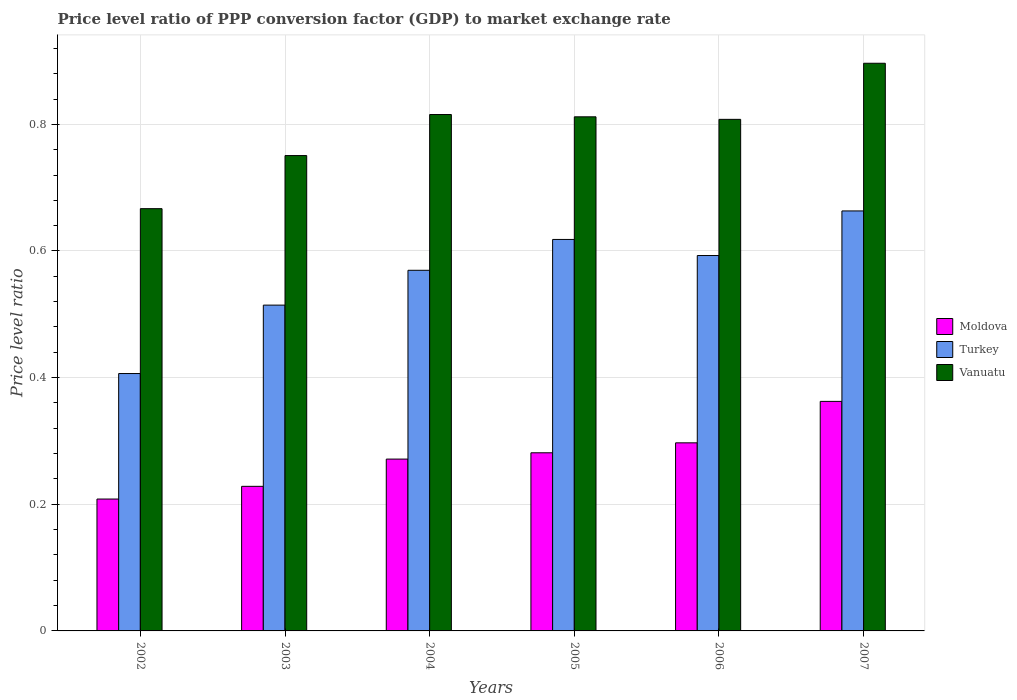Are the number of bars per tick equal to the number of legend labels?
Give a very brief answer. Yes. How many bars are there on the 1st tick from the left?
Give a very brief answer. 3. How many bars are there on the 6th tick from the right?
Give a very brief answer. 3. What is the label of the 2nd group of bars from the left?
Ensure brevity in your answer.  2003. What is the price level ratio in Moldova in 2006?
Ensure brevity in your answer.  0.3. Across all years, what is the maximum price level ratio in Turkey?
Offer a very short reply. 0.66. Across all years, what is the minimum price level ratio in Turkey?
Give a very brief answer. 0.41. In which year was the price level ratio in Turkey maximum?
Offer a very short reply. 2007. What is the total price level ratio in Vanuatu in the graph?
Offer a terse response. 4.75. What is the difference between the price level ratio in Turkey in 2005 and that in 2006?
Give a very brief answer. 0.03. What is the difference between the price level ratio in Vanuatu in 2005 and the price level ratio in Turkey in 2006?
Ensure brevity in your answer.  0.22. What is the average price level ratio in Turkey per year?
Make the answer very short. 0.56. In the year 2006, what is the difference between the price level ratio in Turkey and price level ratio in Moldova?
Your answer should be very brief. 0.3. In how many years, is the price level ratio in Moldova greater than 0.24000000000000002?
Your answer should be very brief. 4. What is the ratio of the price level ratio in Moldova in 2002 to that in 2005?
Your response must be concise. 0.74. Is the price level ratio in Vanuatu in 2004 less than that in 2007?
Offer a very short reply. Yes. Is the difference between the price level ratio in Turkey in 2002 and 2006 greater than the difference between the price level ratio in Moldova in 2002 and 2006?
Provide a short and direct response. No. What is the difference between the highest and the second highest price level ratio in Moldova?
Your answer should be very brief. 0.07. What is the difference between the highest and the lowest price level ratio in Turkey?
Keep it short and to the point. 0.26. In how many years, is the price level ratio in Turkey greater than the average price level ratio in Turkey taken over all years?
Make the answer very short. 4. Is the sum of the price level ratio in Moldova in 2003 and 2005 greater than the maximum price level ratio in Turkey across all years?
Ensure brevity in your answer.  No. What does the 1st bar from the right in 2002 represents?
Ensure brevity in your answer.  Vanuatu. How many bars are there?
Your response must be concise. 18. What is the difference between two consecutive major ticks on the Y-axis?
Make the answer very short. 0.2. Does the graph contain any zero values?
Your answer should be compact. No. Does the graph contain grids?
Your answer should be compact. Yes. Where does the legend appear in the graph?
Ensure brevity in your answer.  Center right. What is the title of the graph?
Provide a succinct answer. Price level ratio of PPP conversion factor (GDP) to market exchange rate. Does "Spain" appear as one of the legend labels in the graph?
Give a very brief answer. No. What is the label or title of the Y-axis?
Your answer should be very brief. Price level ratio. What is the Price level ratio of Moldova in 2002?
Your response must be concise. 0.21. What is the Price level ratio of Turkey in 2002?
Your answer should be compact. 0.41. What is the Price level ratio of Vanuatu in 2002?
Your answer should be compact. 0.67. What is the Price level ratio in Moldova in 2003?
Make the answer very short. 0.23. What is the Price level ratio of Turkey in 2003?
Your response must be concise. 0.51. What is the Price level ratio of Vanuatu in 2003?
Make the answer very short. 0.75. What is the Price level ratio of Moldova in 2004?
Offer a very short reply. 0.27. What is the Price level ratio in Turkey in 2004?
Your answer should be compact. 0.57. What is the Price level ratio in Vanuatu in 2004?
Give a very brief answer. 0.82. What is the Price level ratio of Moldova in 2005?
Ensure brevity in your answer.  0.28. What is the Price level ratio of Turkey in 2005?
Make the answer very short. 0.62. What is the Price level ratio of Vanuatu in 2005?
Provide a succinct answer. 0.81. What is the Price level ratio of Moldova in 2006?
Your response must be concise. 0.3. What is the Price level ratio in Turkey in 2006?
Your answer should be compact. 0.59. What is the Price level ratio of Vanuatu in 2006?
Your answer should be compact. 0.81. What is the Price level ratio of Moldova in 2007?
Provide a short and direct response. 0.36. What is the Price level ratio in Turkey in 2007?
Keep it short and to the point. 0.66. What is the Price level ratio of Vanuatu in 2007?
Give a very brief answer. 0.9. Across all years, what is the maximum Price level ratio in Moldova?
Your answer should be very brief. 0.36. Across all years, what is the maximum Price level ratio in Turkey?
Provide a short and direct response. 0.66. Across all years, what is the maximum Price level ratio of Vanuatu?
Ensure brevity in your answer.  0.9. Across all years, what is the minimum Price level ratio in Moldova?
Provide a short and direct response. 0.21. Across all years, what is the minimum Price level ratio of Turkey?
Your answer should be compact. 0.41. Across all years, what is the minimum Price level ratio of Vanuatu?
Your answer should be very brief. 0.67. What is the total Price level ratio in Moldova in the graph?
Your response must be concise. 1.65. What is the total Price level ratio of Turkey in the graph?
Ensure brevity in your answer.  3.36. What is the total Price level ratio of Vanuatu in the graph?
Your answer should be compact. 4.75. What is the difference between the Price level ratio of Moldova in 2002 and that in 2003?
Your answer should be compact. -0.02. What is the difference between the Price level ratio in Turkey in 2002 and that in 2003?
Your answer should be very brief. -0.11. What is the difference between the Price level ratio in Vanuatu in 2002 and that in 2003?
Ensure brevity in your answer.  -0.08. What is the difference between the Price level ratio in Moldova in 2002 and that in 2004?
Offer a very short reply. -0.06. What is the difference between the Price level ratio in Turkey in 2002 and that in 2004?
Provide a succinct answer. -0.16. What is the difference between the Price level ratio in Vanuatu in 2002 and that in 2004?
Offer a very short reply. -0.15. What is the difference between the Price level ratio in Moldova in 2002 and that in 2005?
Make the answer very short. -0.07. What is the difference between the Price level ratio in Turkey in 2002 and that in 2005?
Give a very brief answer. -0.21. What is the difference between the Price level ratio of Vanuatu in 2002 and that in 2005?
Keep it short and to the point. -0.15. What is the difference between the Price level ratio of Moldova in 2002 and that in 2006?
Make the answer very short. -0.09. What is the difference between the Price level ratio in Turkey in 2002 and that in 2006?
Your answer should be very brief. -0.19. What is the difference between the Price level ratio of Vanuatu in 2002 and that in 2006?
Ensure brevity in your answer.  -0.14. What is the difference between the Price level ratio of Moldova in 2002 and that in 2007?
Provide a succinct answer. -0.15. What is the difference between the Price level ratio of Turkey in 2002 and that in 2007?
Your answer should be compact. -0.26. What is the difference between the Price level ratio in Vanuatu in 2002 and that in 2007?
Offer a terse response. -0.23. What is the difference between the Price level ratio in Moldova in 2003 and that in 2004?
Offer a very short reply. -0.04. What is the difference between the Price level ratio of Turkey in 2003 and that in 2004?
Your answer should be compact. -0.06. What is the difference between the Price level ratio in Vanuatu in 2003 and that in 2004?
Provide a succinct answer. -0.06. What is the difference between the Price level ratio in Moldova in 2003 and that in 2005?
Your response must be concise. -0.05. What is the difference between the Price level ratio of Turkey in 2003 and that in 2005?
Offer a terse response. -0.1. What is the difference between the Price level ratio in Vanuatu in 2003 and that in 2005?
Provide a short and direct response. -0.06. What is the difference between the Price level ratio in Moldova in 2003 and that in 2006?
Ensure brevity in your answer.  -0.07. What is the difference between the Price level ratio in Turkey in 2003 and that in 2006?
Your answer should be very brief. -0.08. What is the difference between the Price level ratio in Vanuatu in 2003 and that in 2006?
Provide a short and direct response. -0.06. What is the difference between the Price level ratio in Moldova in 2003 and that in 2007?
Your response must be concise. -0.13. What is the difference between the Price level ratio in Turkey in 2003 and that in 2007?
Offer a very short reply. -0.15. What is the difference between the Price level ratio in Vanuatu in 2003 and that in 2007?
Your answer should be compact. -0.15. What is the difference between the Price level ratio of Moldova in 2004 and that in 2005?
Offer a terse response. -0.01. What is the difference between the Price level ratio of Turkey in 2004 and that in 2005?
Keep it short and to the point. -0.05. What is the difference between the Price level ratio in Vanuatu in 2004 and that in 2005?
Provide a succinct answer. 0. What is the difference between the Price level ratio in Moldova in 2004 and that in 2006?
Your response must be concise. -0.03. What is the difference between the Price level ratio of Turkey in 2004 and that in 2006?
Give a very brief answer. -0.02. What is the difference between the Price level ratio of Vanuatu in 2004 and that in 2006?
Keep it short and to the point. 0.01. What is the difference between the Price level ratio of Moldova in 2004 and that in 2007?
Your answer should be compact. -0.09. What is the difference between the Price level ratio in Turkey in 2004 and that in 2007?
Provide a succinct answer. -0.09. What is the difference between the Price level ratio of Vanuatu in 2004 and that in 2007?
Your answer should be very brief. -0.08. What is the difference between the Price level ratio of Moldova in 2005 and that in 2006?
Give a very brief answer. -0.02. What is the difference between the Price level ratio of Turkey in 2005 and that in 2006?
Make the answer very short. 0.03. What is the difference between the Price level ratio of Vanuatu in 2005 and that in 2006?
Give a very brief answer. 0. What is the difference between the Price level ratio in Moldova in 2005 and that in 2007?
Provide a succinct answer. -0.08. What is the difference between the Price level ratio in Turkey in 2005 and that in 2007?
Provide a succinct answer. -0.04. What is the difference between the Price level ratio in Vanuatu in 2005 and that in 2007?
Keep it short and to the point. -0.08. What is the difference between the Price level ratio of Moldova in 2006 and that in 2007?
Offer a terse response. -0.07. What is the difference between the Price level ratio in Turkey in 2006 and that in 2007?
Provide a succinct answer. -0.07. What is the difference between the Price level ratio of Vanuatu in 2006 and that in 2007?
Offer a terse response. -0.09. What is the difference between the Price level ratio of Moldova in 2002 and the Price level ratio of Turkey in 2003?
Your response must be concise. -0.31. What is the difference between the Price level ratio in Moldova in 2002 and the Price level ratio in Vanuatu in 2003?
Your answer should be very brief. -0.54. What is the difference between the Price level ratio of Turkey in 2002 and the Price level ratio of Vanuatu in 2003?
Your answer should be very brief. -0.34. What is the difference between the Price level ratio in Moldova in 2002 and the Price level ratio in Turkey in 2004?
Your answer should be compact. -0.36. What is the difference between the Price level ratio in Moldova in 2002 and the Price level ratio in Vanuatu in 2004?
Offer a terse response. -0.61. What is the difference between the Price level ratio of Turkey in 2002 and the Price level ratio of Vanuatu in 2004?
Make the answer very short. -0.41. What is the difference between the Price level ratio in Moldova in 2002 and the Price level ratio in Turkey in 2005?
Your answer should be compact. -0.41. What is the difference between the Price level ratio in Moldova in 2002 and the Price level ratio in Vanuatu in 2005?
Your response must be concise. -0.6. What is the difference between the Price level ratio of Turkey in 2002 and the Price level ratio of Vanuatu in 2005?
Give a very brief answer. -0.41. What is the difference between the Price level ratio of Moldova in 2002 and the Price level ratio of Turkey in 2006?
Offer a terse response. -0.38. What is the difference between the Price level ratio in Moldova in 2002 and the Price level ratio in Vanuatu in 2006?
Offer a very short reply. -0.6. What is the difference between the Price level ratio in Turkey in 2002 and the Price level ratio in Vanuatu in 2006?
Your answer should be very brief. -0.4. What is the difference between the Price level ratio in Moldova in 2002 and the Price level ratio in Turkey in 2007?
Give a very brief answer. -0.46. What is the difference between the Price level ratio in Moldova in 2002 and the Price level ratio in Vanuatu in 2007?
Your answer should be very brief. -0.69. What is the difference between the Price level ratio in Turkey in 2002 and the Price level ratio in Vanuatu in 2007?
Keep it short and to the point. -0.49. What is the difference between the Price level ratio of Moldova in 2003 and the Price level ratio of Turkey in 2004?
Your response must be concise. -0.34. What is the difference between the Price level ratio in Moldova in 2003 and the Price level ratio in Vanuatu in 2004?
Offer a terse response. -0.59. What is the difference between the Price level ratio of Turkey in 2003 and the Price level ratio of Vanuatu in 2004?
Your answer should be compact. -0.3. What is the difference between the Price level ratio in Moldova in 2003 and the Price level ratio in Turkey in 2005?
Your answer should be very brief. -0.39. What is the difference between the Price level ratio of Moldova in 2003 and the Price level ratio of Vanuatu in 2005?
Ensure brevity in your answer.  -0.58. What is the difference between the Price level ratio in Turkey in 2003 and the Price level ratio in Vanuatu in 2005?
Keep it short and to the point. -0.3. What is the difference between the Price level ratio in Moldova in 2003 and the Price level ratio in Turkey in 2006?
Your answer should be compact. -0.36. What is the difference between the Price level ratio of Moldova in 2003 and the Price level ratio of Vanuatu in 2006?
Provide a succinct answer. -0.58. What is the difference between the Price level ratio of Turkey in 2003 and the Price level ratio of Vanuatu in 2006?
Ensure brevity in your answer.  -0.29. What is the difference between the Price level ratio in Moldova in 2003 and the Price level ratio in Turkey in 2007?
Your response must be concise. -0.43. What is the difference between the Price level ratio of Moldova in 2003 and the Price level ratio of Vanuatu in 2007?
Offer a very short reply. -0.67. What is the difference between the Price level ratio of Turkey in 2003 and the Price level ratio of Vanuatu in 2007?
Provide a short and direct response. -0.38. What is the difference between the Price level ratio of Moldova in 2004 and the Price level ratio of Turkey in 2005?
Your answer should be compact. -0.35. What is the difference between the Price level ratio of Moldova in 2004 and the Price level ratio of Vanuatu in 2005?
Make the answer very short. -0.54. What is the difference between the Price level ratio in Turkey in 2004 and the Price level ratio in Vanuatu in 2005?
Give a very brief answer. -0.24. What is the difference between the Price level ratio of Moldova in 2004 and the Price level ratio of Turkey in 2006?
Offer a very short reply. -0.32. What is the difference between the Price level ratio of Moldova in 2004 and the Price level ratio of Vanuatu in 2006?
Give a very brief answer. -0.54. What is the difference between the Price level ratio in Turkey in 2004 and the Price level ratio in Vanuatu in 2006?
Keep it short and to the point. -0.24. What is the difference between the Price level ratio of Moldova in 2004 and the Price level ratio of Turkey in 2007?
Keep it short and to the point. -0.39. What is the difference between the Price level ratio in Moldova in 2004 and the Price level ratio in Vanuatu in 2007?
Keep it short and to the point. -0.63. What is the difference between the Price level ratio in Turkey in 2004 and the Price level ratio in Vanuatu in 2007?
Make the answer very short. -0.33. What is the difference between the Price level ratio of Moldova in 2005 and the Price level ratio of Turkey in 2006?
Your answer should be very brief. -0.31. What is the difference between the Price level ratio in Moldova in 2005 and the Price level ratio in Vanuatu in 2006?
Give a very brief answer. -0.53. What is the difference between the Price level ratio in Turkey in 2005 and the Price level ratio in Vanuatu in 2006?
Provide a short and direct response. -0.19. What is the difference between the Price level ratio in Moldova in 2005 and the Price level ratio in Turkey in 2007?
Offer a very short reply. -0.38. What is the difference between the Price level ratio in Moldova in 2005 and the Price level ratio in Vanuatu in 2007?
Your response must be concise. -0.62. What is the difference between the Price level ratio of Turkey in 2005 and the Price level ratio of Vanuatu in 2007?
Your answer should be very brief. -0.28. What is the difference between the Price level ratio of Moldova in 2006 and the Price level ratio of Turkey in 2007?
Ensure brevity in your answer.  -0.37. What is the difference between the Price level ratio of Moldova in 2006 and the Price level ratio of Vanuatu in 2007?
Ensure brevity in your answer.  -0.6. What is the difference between the Price level ratio of Turkey in 2006 and the Price level ratio of Vanuatu in 2007?
Your response must be concise. -0.3. What is the average Price level ratio of Moldova per year?
Your answer should be compact. 0.27. What is the average Price level ratio of Turkey per year?
Offer a terse response. 0.56. What is the average Price level ratio of Vanuatu per year?
Your answer should be compact. 0.79. In the year 2002, what is the difference between the Price level ratio in Moldova and Price level ratio in Turkey?
Offer a very short reply. -0.2. In the year 2002, what is the difference between the Price level ratio of Moldova and Price level ratio of Vanuatu?
Make the answer very short. -0.46. In the year 2002, what is the difference between the Price level ratio in Turkey and Price level ratio in Vanuatu?
Ensure brevity in your answer.  -0.26. In the year 2003, what is the difference between the Price level ratio of Moldova and Price level ratio of Turkey?
Your answer should be compact. -0.29. In the year 2003, what is the difference between the Price level ratio of Moldova and Price level ratio of Vanuatu?
Your answer should be compact. -0.52. In the year 2003, what is the difference between the Price level ratio of Turkey and Price level ratio of Vanuatu?
Give a very brief answer. -0.24. In the year 2004, what is the difference between the Price level ratio of Moldova and Price level ratio of Turkey?
Provide a succinct answer. -0.3. In the year 2004, what is the difference between the Price level ratio of Moldova and Price level ratio of Vanuatu?
Offer a very short reply. -0.54. In the year 2004, what is the difference between the Price level ratio of Turkey and Price level ratio of Vanuatu?
Provide a succinct answer. -0.25. In the year 2005, what is the difference between the Price level ratio of Moldova and Price level ratio of Turkey?
Your answer should be very brief. -0.34. In the year 2005, what is the difference between the Price level ratio of Moldova and Price level ratio of Vanuatu?
Keep it short and to the point. -0.53. In the year 2005, what is the difference between the Price level ratio in Turkey and Price level ratio in Vanuatu?
Offer a terse response. -0.19. In the year 2006, what is the difference between the Price level ratio in Moldova and Price level ratio in Turkey?
Offer a terse response. -0.3. In the year 2006, what is the difference between the Price level ratio of Moldova and Price level ratio of Vanuatu?
Your response must be concise. -0.51. In the year 2006, what is the difference between the Price level ratio in Turkey and Price level ratio in Vanuatu?
Offer a terse response. -0.22. In the year 2007, what is the difference between the Price level ratio in Moldova and Price level ratio in Turkey?
Your response must be concise. -0.3. In the year 2007, what is the difference between the Price level ratio in Moldova and Price level ratio in Vanuatu?
Provide a short and direct response. -0.53. In the year 2007, what is the difference between the Price level ratio in Turkey and Price level ratio in Vanuatu?
Ensure brevity in your answer.  -0.23. What is the ratio of the Price level ratio in Moldova in 2002 to that in 2003?
Provide a succinct answer. 0.91. What is the ratio of the Price level ratio of Turkey in 2002 to that in 2003?
Make the answer very short. 0.79. What is the ratio of the Price level ratio of Vanuatu in 2002 to that in 2003?
Make the answer very short. 0.89. What is the ratio of the Price level ratio in Moldova in 2002 to that in 2004?
Offer a terse response. 0.77. What is the ratio of the Price level ratio of Turkey in 2002 to that in 2004?
Give a very brief answer. 0.71. What is the ratio of the Price level ratio of Vanuatu in 2002 to that in 2004?
Your response must be concise. 0.82. What is the ratio of the Price level ratio of Moldova in 2002 to that in 2005?
Make the answer very short. 0.74. What is the ratio of the Price level ratio of Turkey in 2002 to that in 2005?
Offer a very short reply. 0.66. What is the ratio of the Price level ratio in Vanuatu in 2002 to that in 2005?
Provide a succinct answer. 0.82. What is the ratio of the Price level ratio of Moldova in 2002 to that in 2006?
Provide a short and direct response. 0.7. What is the ratio of the Price level ratio of Turkey in 2002 to that in 2006?
Offer a terse response. 0.69. What is the ratio of the Price level ratio of Vanuatu in 2002 to that in 2006?
Provide a short and direct response. 0.83. What is the ratio of the Price level ratio in Moldova in 2002 to that in 2007?
Keep it short and to the point. 0.57. What is the ratio of the Price level ratio of Turkey in 2002 to that in 2007?
Keep it short and to the point. 0.61. What is the ratio of the Price level ratio of Vanuatu in 2002 to that in 2007?
Your response must be concise. 0.74. What is the ratio of the Price level ratio of Moldova in 2003 to that in 2004?
Offer a very short reply. 0.84. What is the ratio of the Price level ratio of Turkey in 2003 to that in 2004?
Keep it short and to the point. 0.9. What is the ratio of the Price level ratio of Vanuatu in 2003 to that in 2004?
Keep it short and to the point. 0.92. What is the ratio of the Price level ratio of Moldova in 2003 to that in 2005?
Provide a short and direct response. 0.81. What is the ratio of the Price level ratio of Turkey in 2003 to that in 2005?
Your response must be concise. 0.83. What is the ratio of the Price level ratio in Vanuatu in 2003 to that in 2005?
Keep it short and to the point. 0.92. What is the ratio of the Price level ratio in Moldova in 2003 to that in 2006?
Make the answer very short. 0.77. What is the ratio of the Price level ratio of Turkey in 2003 to that in 2006?
Provide a short and direct response. 0.87. What is the ratio of the Price level ratio of Vanuatu in 2003 to that in 2006?
Provide a succinct answer. 0.93. What is the ratio of the Price level ratio of Moldova in 2003 to that in 2007?
Ensure brevity in your answer.  0.63. What is the ratio of the Price level ratio in Turkey in 2003 to that in 2007?
Ensure brevity in your answer.  0.78. What is the ratio of the Price level ratio of Vanuatu in 2003 to that in 2007?
Keep it short and to the point. 0.84. What is the ratio of the Price level ratio of Moldova in 2004 to that in 2005?
Give a very brief answer. 0.96. What is the ratio of the Price level ratio of Turkey in 2004 to that in 2005?
Offer a terse response. 0.92. What is the ratio of the Price level ratio of Vanuatu in 2004 to that in 2005?
Keep it short and to the point. 1. What is the ratio of the Price level ratio of Moldova in 2004 to that in 2006?
Your answer should be very brief. 0.91. What is the ratio of the Price level ratio in Turkey in 2004 to that in 2006?
Offer a terse response. 0.96. What is the ratio of the Price level ratio of Vanuatu in 2004 to that in 2006?
Give a very brief answer. 1.01. What is the ratio of the Price level ratio in Moldova in 2004 to that in 2007?
Keep it short and to the point. 0.75. What is the ratio of the Price level ratio in Turkey in 2004 to that in 2007?
Give a very brief answer. 0.86. What is the ratio of the Price level ratio of Vanuatu in 2004 to that in 2007?
Provide a succinct answer. 0.91. What is the ratio of the Price level ratio of Moldova in 2005 to that in 2006?
Give a very brief answer. 0.95. What is the ratio of the Price level ratio of Turkey in 2005 to that in 2006?
Provide a short and direct response. 1.04. What is the ratio of the Price level ratio of Moldova in 2005 to that in 2007?
Offer a very short reply. 0.78. What is the ratio of the Price level ratio in Turkey in 2005 to that in 2007?
Provide a short and direct response. 0.93. What is the ratio of the Price level ratio in Vanuatu in 2005 to that in 2007?
Your answer should be compact. 0.91. What is the ratio of the Price level ratio of Moldova in 2006 to that in 2007?
Offer a very short reply. 0.82. What is the ratio of the Price level ratio in Turkey in 2006 to that in 2007?
Your answer should be compact. 0.89. What is the ratio of the Price level ratio in Vanuatu in 2006 to that in 2007?
Your answer should be very brief. 0.9. What is the difference between the highest and the second highest Price level ratio of Moldova?
Offer a very short reply. 0.07. What is the difference between the highest and the second highest Price level ratio of Turkey?
Your answer should be very brief. 0.04. What is the difference between the highest and the second highest Price level ratio in Vanuatu?
Offer a terse response. 0.08. What is the difference between the highest and the lowest Price level ratio of Moldova?
Make the answer very short. 0.15. What is the difference between the highest and the lowest Price level ratio of Turkey?
Your answer should be very brief. 0.26. What is the difference between the highest and the lowest Price level ratio in Vanuatu?
Provide a short and direct response. 0.23. 